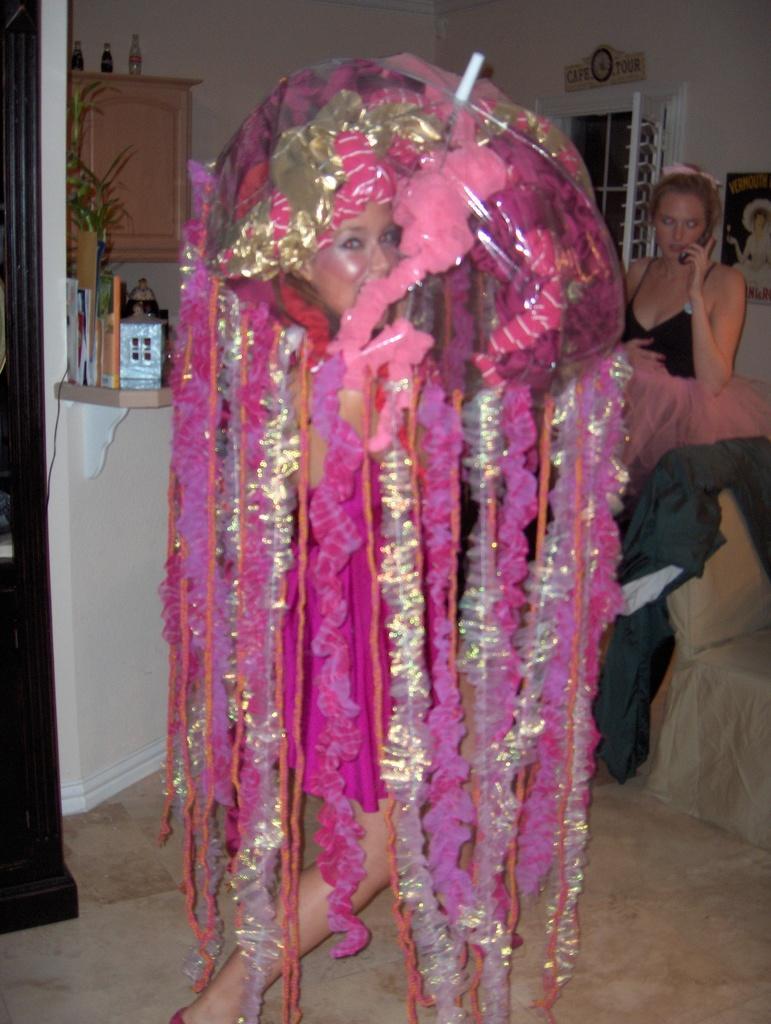In one or two sentences, can you explain what this image depicts? In the image there is a lady with jellyfish costume is standing. On the left side of the image there is a pillar. Beside the pillar on the wall there is a wooden object with few items on it. And also there is a cupboard with bottles on it. On the right side of the image there is a chair with cloth. Behind the chair there is a lady standing and holding an object in her hand. Behind her there is a wall with poster and a window. At the top of the window there is an object on the wall. 